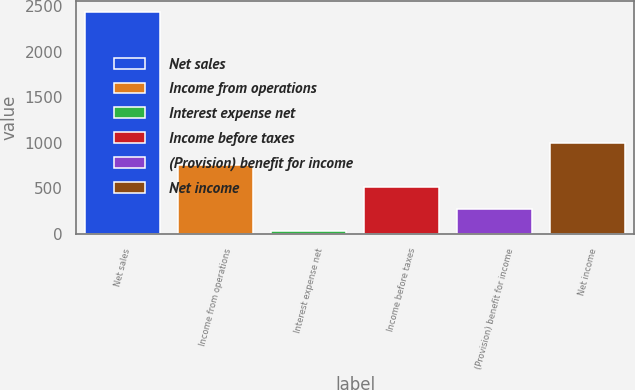Convert chart to OTSL. <chart><loc_0><loc_0><loc_500><loc_500><bar_chart><fcel>Net sales<fcel>Income from operations<fcel>Interest expense net<fcel>Income before taxes<fcel>(Provision) benefit for income<fcel>Net income<nl><fcel>2435.6<fcel>753.29<fcel>32.3<fcel>512.96<fcel>272.63<fcel>993.62<nl></chart> 